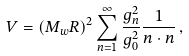Convert formula to latex. <formula><loc_0><loc_0><loc_500><loc_500>V = ( M _ { w } R ) ^ { 2 } \sum _ { { n } = 1 } ^ { \infty } { \frac { g _ { n } ^ { 2 } } { g _ { 0 } ^ { 2 } } } { \frac { 1 } { { n } \cdot { n } } } \, ,</formula> 